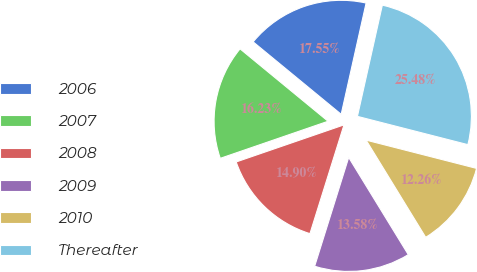<chart> <loc_0><loc_0><loc_500><loc_500><pie_chart><fcel>2006<fcel>2007<fcel>2008<fcel>2009<fcel>2010<fcel>Thereafter<nl><fcel>17.55%<fcel>16.23%<fcel>14.9%<fcel>13.58%<fcel>12.26%<fcel>25.48%<nl></chart> 